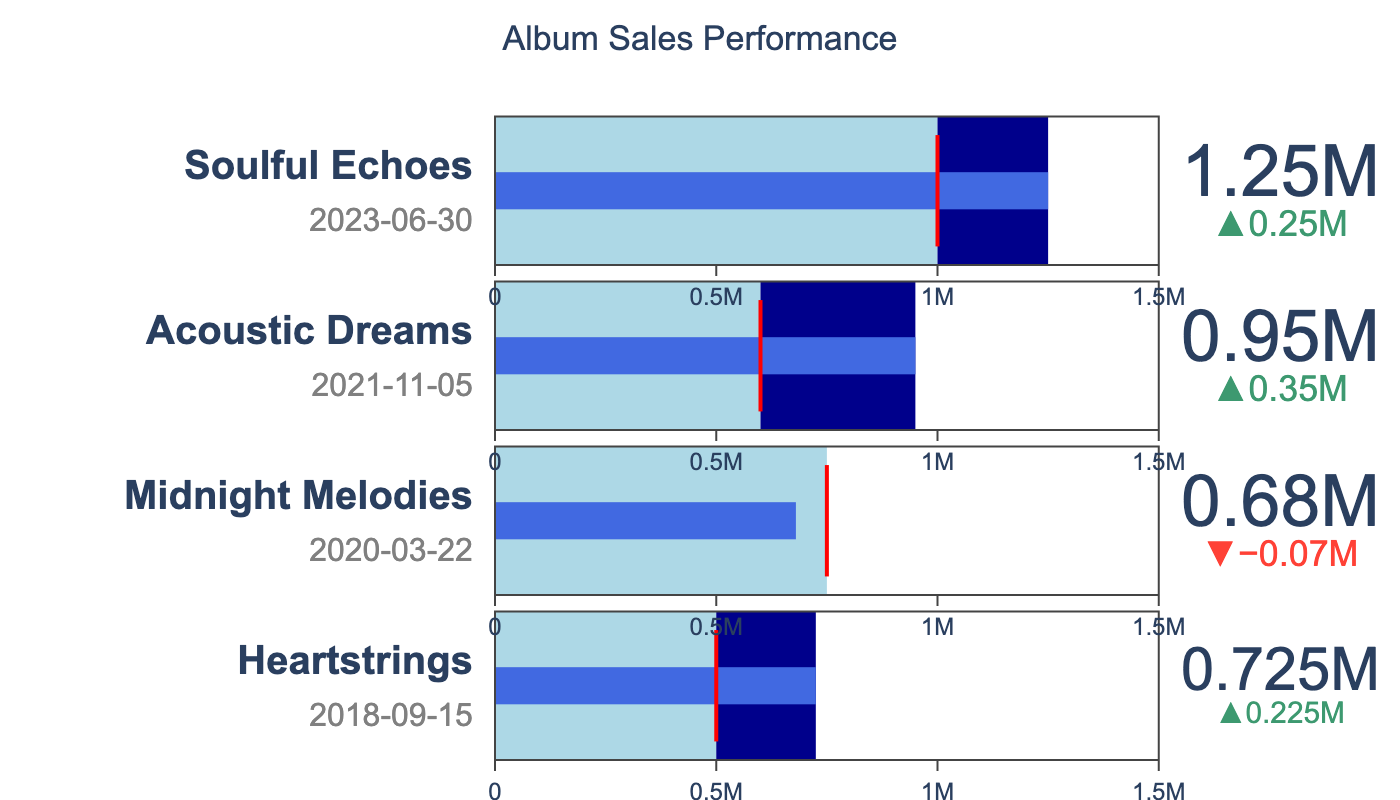What is the title of the figure? The figure title is centered at the top and clearly states the purpose of the plot.
Answer: Album Sales Performance How many albums are shown in the Bullet Chart? The Bullet Chart has four separate sections, each corresponding to a different album.
Answer: Four What is the release date of "Soulful Echoes"? Each album section has a title with the album name and release date. For "Soulful Echoes," the date is under the title.
Answer: 2023-06-30 Which album had the highest actual sales? In each section, the value is labeled, and for "Soulful Echoes," the actual sales value is the highest among the others.
Answer: Soulful Echoes What's the difference between the actual sales and target sales for "Midnight Melodies"? Identify the 'Actual Sales' and 'Target Sales' for "Midnight Melodies" and compute the difference: 680,000 - 750,000.
Answer: -70,000 Which album exceeded its target sales by the largest margin? Calculate the difference between 'Actual Sales' and 'Target Sales' for each album and identify the album with the largest difference: "Acoustic Dreams" had a difference of 950,000 - 600,000 = 350,000.
Answer: Acoustic Dreams Compare the actual sales of "Heartstrings" and "Midnight Melodies." Which one is higher? Look at the actual sales values for both albums: 725,000 for "Heartstrings" and 680,000 for "Midnight Melodies." "Heartstrings" has higher actual sales.
Answer: Heartstrings How much more did "Acoustic Dreams" sell compared to its target? Determine the difference between the actual and target sales for "Acoustic Dreams": 950,000 - 600,000.
Answer: 350,000 Are there any albums that did not meet their target sales? If so, which ones? Check if the actual sales are less than the target sales for each album. "Midnight Melodies" has actual sales of 680,000 which is less than its target of 750,000.
Answer: Midnight Melodies What is the total actual sales across all albums? Sum the actual sales values of all albums: 725,000 + 680,000 + 950,000 + 1,250,000 = 3,605,000.
Answer: 3,605,000 Considering the release date, which album was released first and which one last? Sort the albums by their release dates. "Heartstrings" was released first (2018-09-15) and "Soulful Echoes" last (2023-06-30).
Answer: First: Heartstrings, Last: Soulful Echoes 